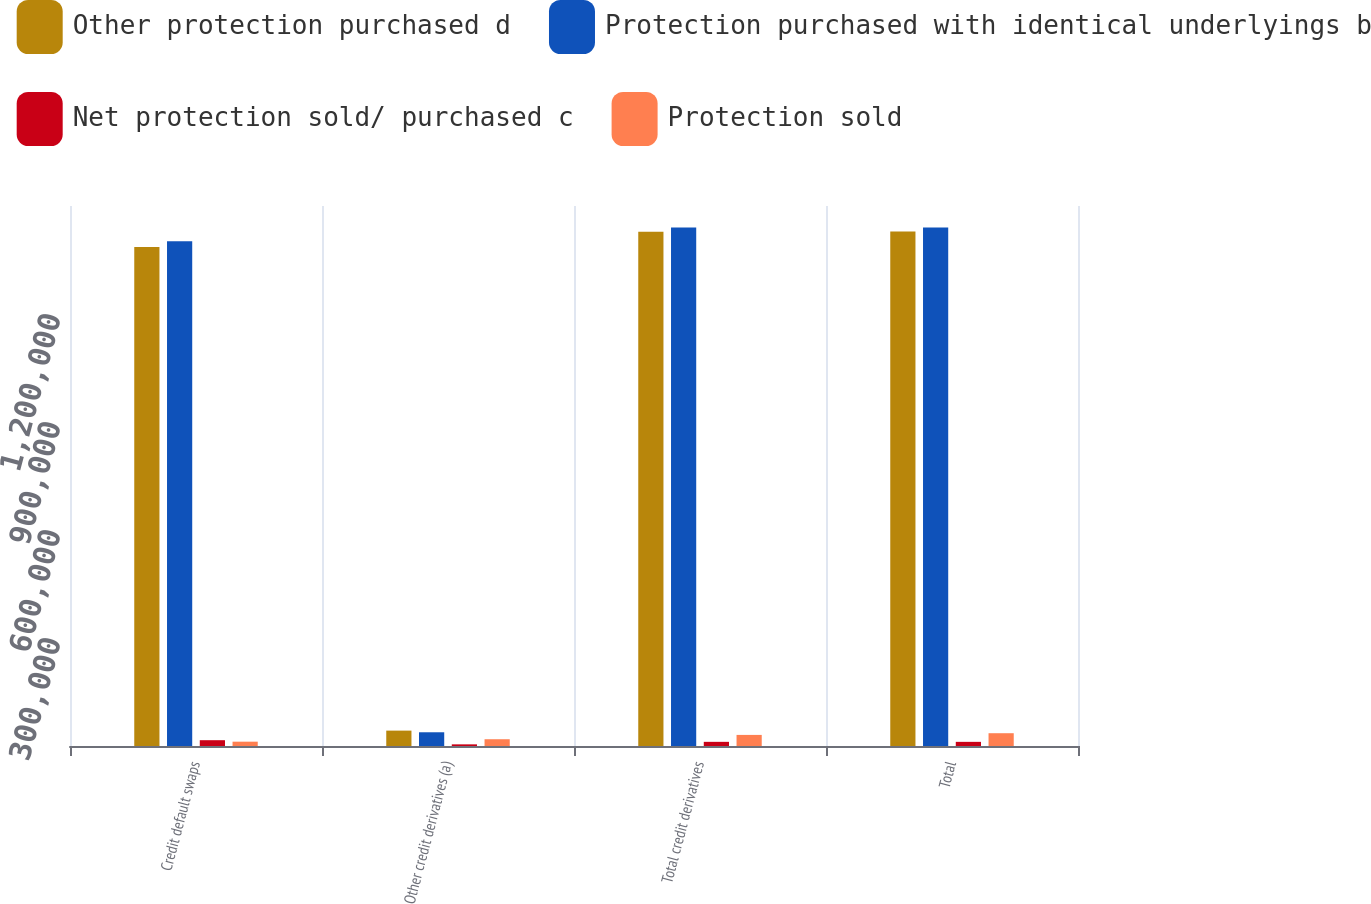<chart> <loc_0><loc_0><loc_500><loc_500><stacked_bar_chart><ecel><fcel>Credit default swaps<fcel>Other credit derivatives (a)<fcel>Total credit derivatives<fcel>Total<nl><fcel>Other protection purchased d<fcel>1.38607e+06<fcel>42738<fcel>1.42881e+06<fcel>1.42884e+06<nl><fcel>Protection purchased with identical underlyings b<fcel>1.4022e+06<fcel>38158<fcel>1.44036e+06<fcel>1.44036e+06<nl><fcel>Net protection sold/ purchased c<fcel>16130<fcel>4580<fcel>11550<fcel>11520<nl><fcel>Protection sold<fcel>12011<fcel>18792<fcel>30803<fcel>35518<nl></chart> 